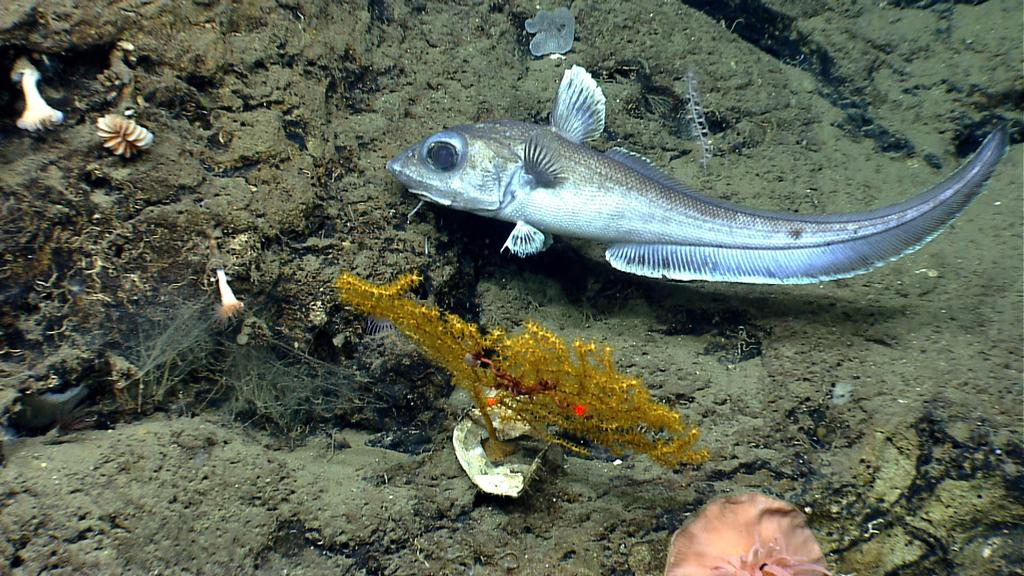What type of animals can be seen in the image? There are fish in the image. What other living organism is present in the image? There is a plant in the image. What else can be seen in the image besides the fish and plant? There are objects in the image. What is the surface on which the fish and plant are situated? The ground is visible in the image. What type of business is being conducted in the image? There is no indication of a business or any business-related activities in the image. 